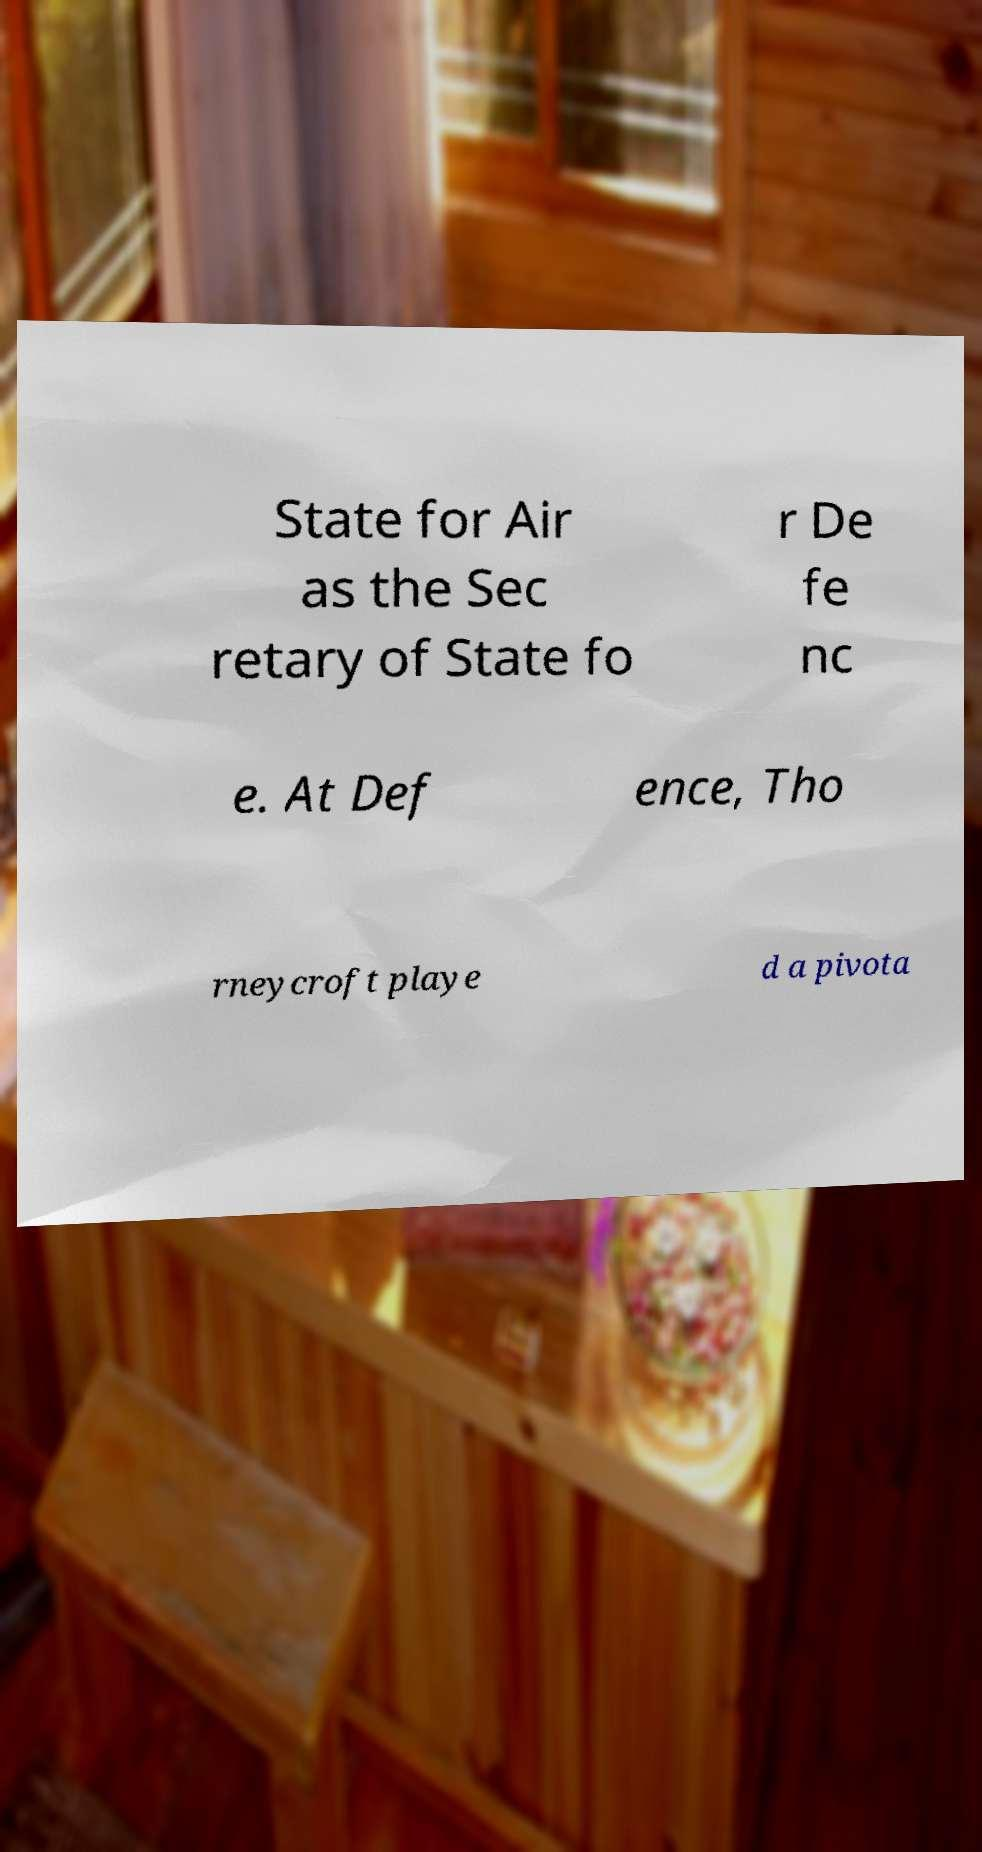Could you assist in decoding the text presented in this image and type it out clearly? State for Air as the Sec retary of State fo r De fe nc e. At Def ence, Tho rneycroft playe d a pivota 